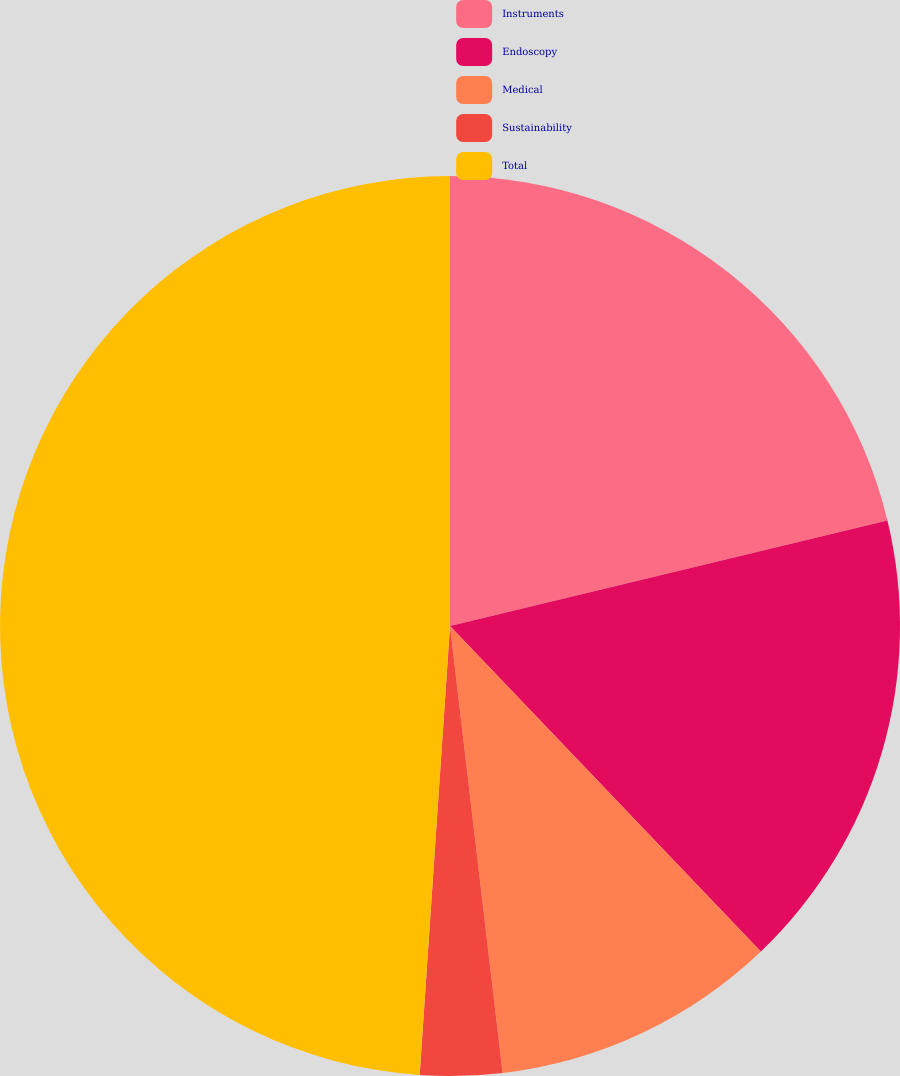Convert chart. <chart><loc_0><loc_0><loc_500><loc_500><pie_chart><fcel>Instruments<fcel>Endoscopy<fcel>Medical<fcel>Sustainability<fcel>Total<nl><fcel>21.23%<fcel>16.63%<fcel>10.27%<fcel>2.94%<fcel>48.92%<nl></chart> 